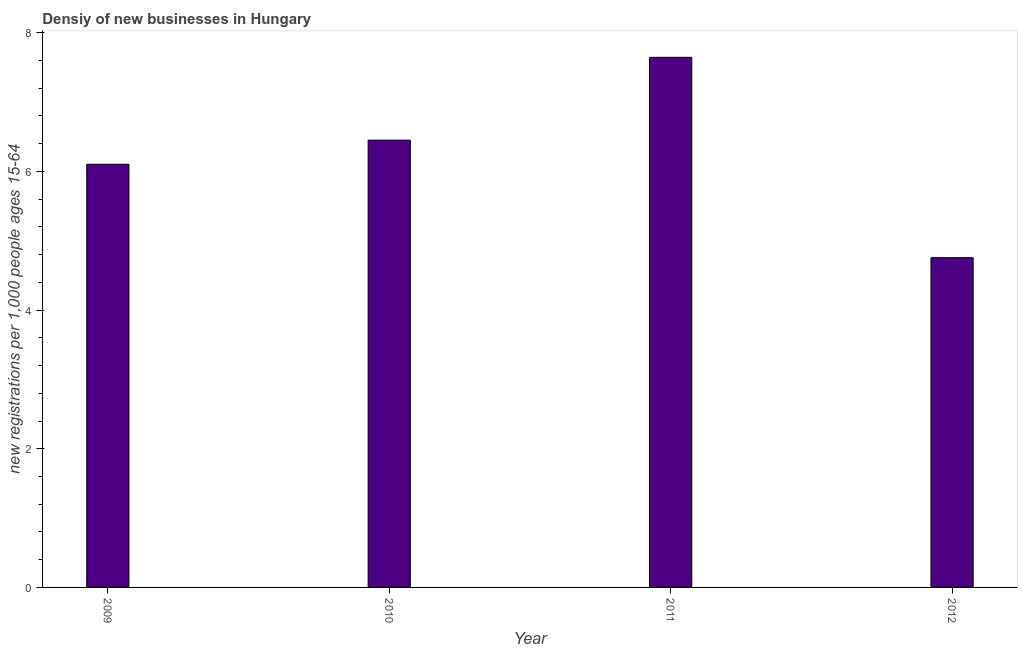Does the graph contain any zero values?
Provide a succinct answer. No. What is the title of the graph?
Provide a short and direct response. Densiy of new businesses in Hungary. What is the label or title of the Y-axis?
Your response must be concise. New registrations per 1,0 people ages 15-64. What is the density of new business in 2010?
Your answer should be compact. 6.45. Across all years, what is the maximum density of new business?
Make the answer very short. 7.64. Across all years, what is the minimum density of new business?
Your response must be concise. 4.75. In which year was the density of new business minimum?
Offer a very short reply. 2012. What is the sum of the density of new business?
Offer a terse response. 24.95. What is the difference between the density of new business in 2010 and 2011?
Offer a terse response. -1.2. What is the average density of new business per year?
Provide a short and direct response. 6.24. What is the median density of new business?
Provide a short and direct response. 6.28. In how many years, is the density of new business greater than 4.8 ?
Ensure brevity in your answer.  3. Do a majority of the years between 2011 and 2012 (inclusive) have density of new business greater than 4.8 ?
Give a very brief answer. No. What is the ratio of the density of new business in 2010 to that in 2011?
Give a very brief answer. 0.84. Is the density of new business in 2009 less than that in 2011?
Your answer should be very brief. Yes. Is the difference between the density of new business in 2010 and 2012 greater than the difference between any two years?
Give a very brief answer. No. What is the difference between the highest and the second highest density of new business?
Offer a terse response. 1.2. What is the difference between the highest and the lowest density of new business?
Give a very brief answer. 2.89. In how many years, is the density of new business greater than the average density of new business taken over all years?
Offer a very short reply. 2. How many bars are there?
Your answer should be very brief. 4. Are all the bars in the graph horizontal?
Your answer should be very brief. No. How many years are there in the graph?
Make the answer very short. 4. What is the difference between two consecutive major ticks on the Y-axis?
Offer a very short reply. 2. Are the values on the major ticks of Y-axis written in scientific E-notation?
Provide a short and direct response. No. What is the new registrations per 1,000 people ages 15-64 in 2009?
Make the answer very short. 6.1. What is the new registrations per 1,000 people ages 15-64 of 2010?
Give a very brief answer. 6.45. What is the new registrations per 1,000 people ages 15-64 of 2011?
Provide a short and direct response. 7.64. What is the new registrations per 1,000 people ages 15-64 of 2012?
Your response must be concise. 4.75. What is the difference between the new registrations per 1,000 people ages 15-64 in 2009 and 2010?
Make the answer very short. -0.35. What is the difference between the new registrations per 1,000 people ages 15-64 in 2009 and 2011?
Offer a terse response. -1.54. What is the difference between the new registrations per 1,000 people ages 15-64 in 2009 and 2012?
Provide a short and direct response. 1.35. What is the difference between the new registrations per 1,000 people ages 15-64 in 2010 and 2011?
Ensure brevity in your answer.  -1.19. What is the difference between the new registrations per 1,000 people ages 15-64 in 2010 and 2012?
Provide a succinct answer. 1.69. What is the difference between the new registrations per 1,000 people ages 15-64 in 2011 and 2012?
Your answer should be very brief. 2.89. What is the ratio of the new registrations per 1,000 people ages 15-64 in 2009 to that in 2010?
Your answer should be very brief. 0.95. What is the ratio of the new registrations per 1,000 people ages 15-64 in 2009 to that in 2011?
Ensure brevity in your answer.  0.8. What is the ratio of the new registrations per 1,000 people ages 15-64 in 2009 to that in 2012?
Ensure brevity in your answer.  1.28. What is the ratio of the new registrations per 1,000 people ages 15-64 in 2010 to that in 2011?
Offer a very short reply. 0.84. What is the ratio of the new registrations per 1,000 people ages 15-64 in 2010 to that in 2012?
Offer a terse response. 1.36. What is the ratio of the new registrations per 1,000 people ages 15-64 in 2011 to that in 2012?
Make the answer very short. 1.61. 